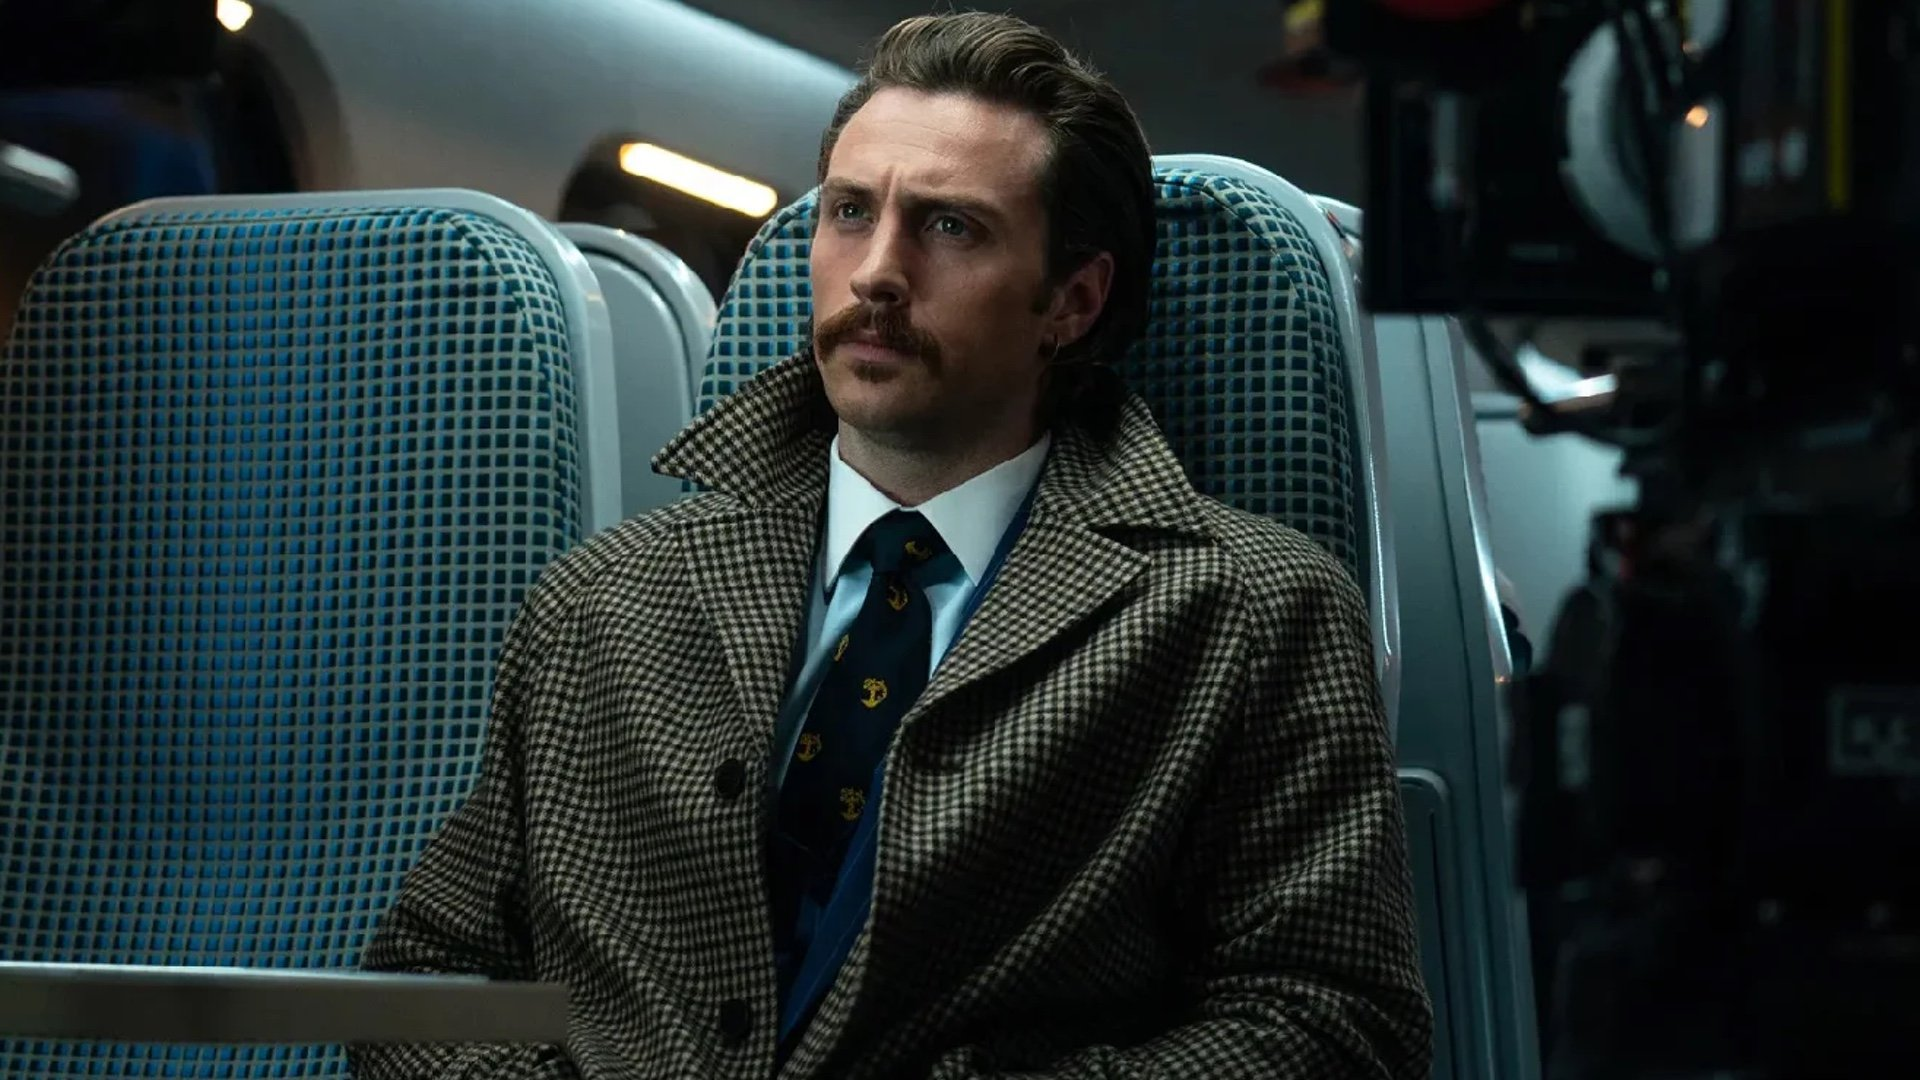What do you think is going on in this snapshot? In the image, the character, depicted with a contemplative expression and dressed in a distinguished houndstooth coat paired with a blue tie featuring gold horse motifs, seems to be deeply absorbed in thought. The setting is a train car, indicated by the patterned blue seats and the general layout, which frames the scene with a cinematic quality. This snapshot captures a moment that suggests a blend of suspense and introspection, hinting at the complex narrative woven into the storyline of the movie 'Nocturnal Animals', where themes of revenge and redemption play a central role. 